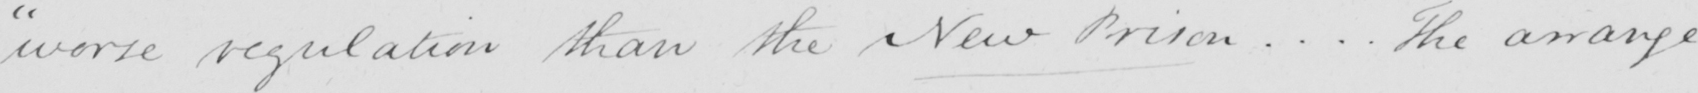What is written in this line of handwriting? " worse regulation than the New Prison ... . The arrange- 